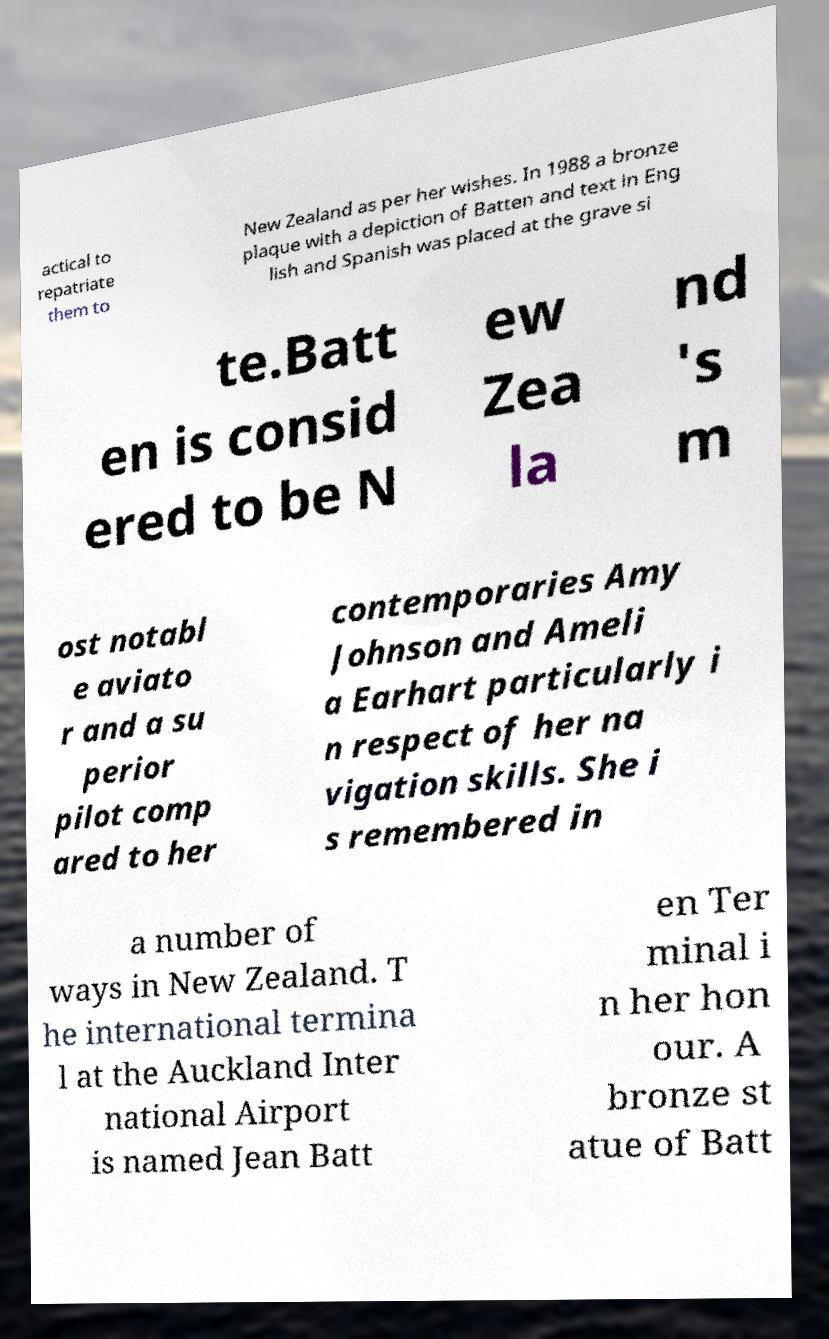What messages or text are displayed in this image? I need them in a readable, typed format. actical to repatriate them to New Zealand as per her wishes. In 1988 a bronze plaque with a depiction of Batten and text in Eng lish and Spanish was placed at the grave si te.Batt en is consid ered to be N ew Zea la nd 's m ost notabl e aviato r and a su perior pilot comp ared to her contemporaries Amy Johnson and Ameli a Earhart particularly i n respect of her na vigation skills. She i s remembered in a number of ways in New Zealand. T he international termina l at the Auckland Inter national Airport is named Jean Batt en Ter minal i n her hon our. A bronze st atue of Batt 